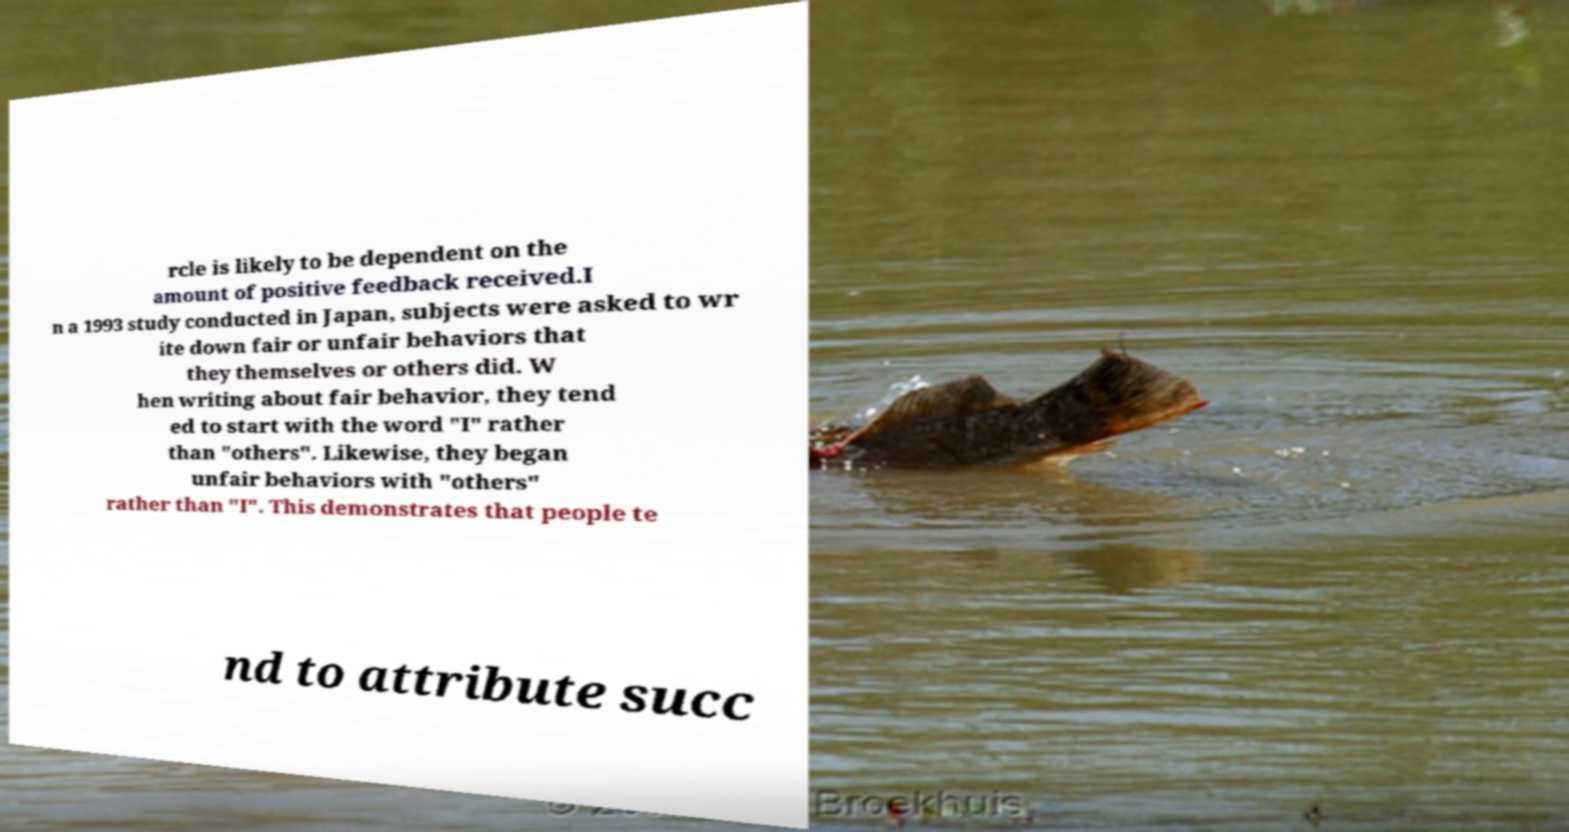Can you accurately transcribe the text from the provided image for me? rcle is likely to be dependent on the amount of positive feedback received.I n a 1993 study conducted in Japan, subjects were asked to wr ite down fair or unfair behaviors that they themselves or others did. W hen writing about fair behavior, they tend ed to start with the word "I" rather than "others". Likewise, they began unfair behaviors with "others" rather than "I". This demonstrates that people te nd to attribute succ 